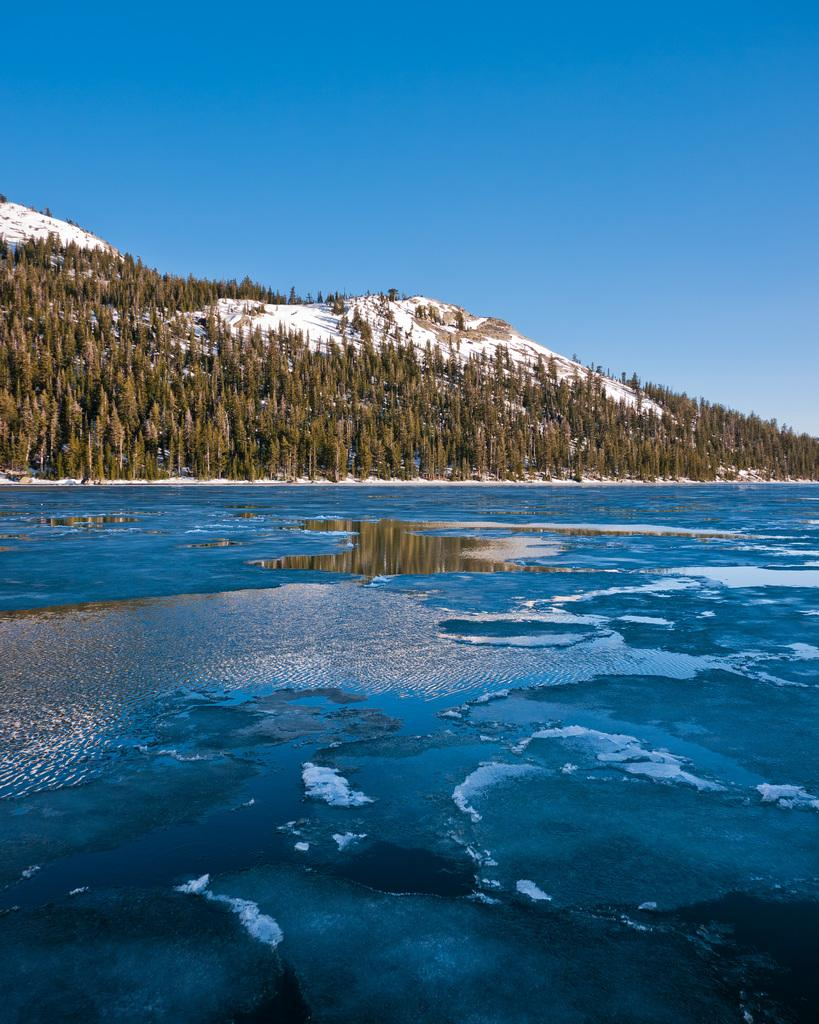What is the primary element visible in the image? There is water in the image. What type of natural vegetation can be seen in the image? There are trees in the image. What geographical feature is present in the image? There are mountains with snow in the image. What part of the natural environment is visible in the image? The sky is visible in the image. What type of pot is visible in the image? There is no pot present in the image. What substance is being used to reach the end of the image? The image does not depict a journey or destination, so there is no need to reach an end, and no substance is used to do so. 